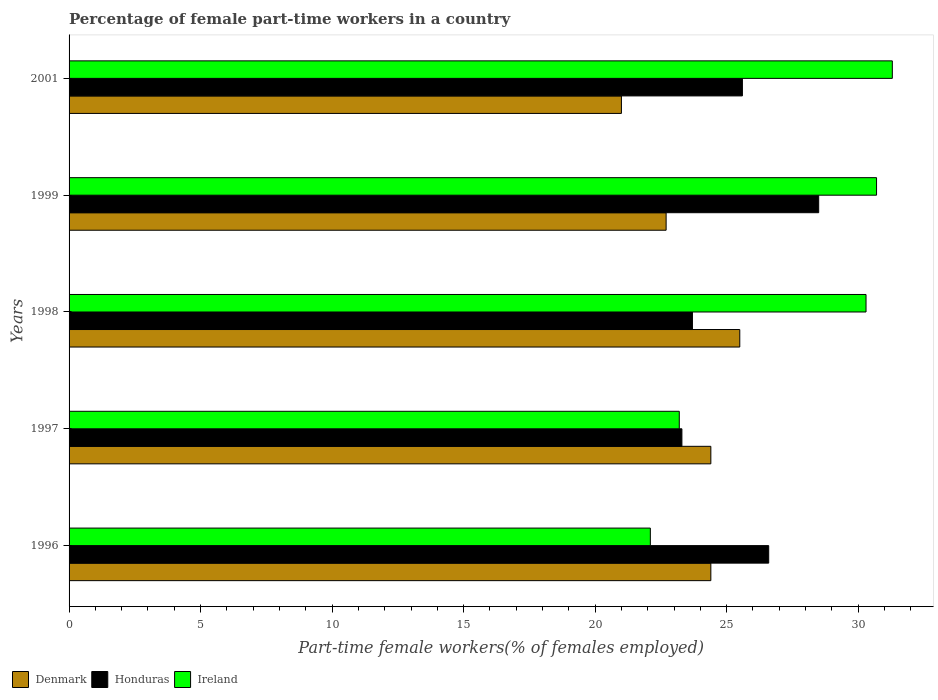How many different coloured bars are there?
Your answer should be compact. 3. Are the number of bars per tick equal to the number of legend labels?
Your answer should be compact. Yes. How many bars are there on the 4th tick from the bottom?
Keep it short and to the point. 3. What is the label of the 1st group of bars from the top?
Offer a terse response. 2001. What is the percentage of female part-time workers in Denmark in 1998?
Offer a very short reply. 25.5. In which year was the percentage of female part-time workers in Honduras minimum?
Give a very brief answer. 1997. What is the total percentage of female part-time workers in Honduras in the graph?
Your answer should be very brief. 127.7. What is the difference between the percentage of female part-time workers in Honduras in 1998 and that in 1999?
Provide a short and direct response. -4.8. What is the difference between the percentage of female part-time workers in Denmark in 1998 and the percentage of female part-time workers in Honduras in 2001?
Offer a terse response. -0.1. What is the average percentage of female part-time workers in Denmark per year?
Keep it short and to the point. 23.6. In the year 1997, what is the difference between the percentage of female part-time workers in Ireland and percentage of female part-time workers in Denmark?
Provide a succinct answer. -1.2. In how many years, is the percentage of female part-time workers in Ireland greater than 17 %?
Offer a terse response. 5. What is the ratio of the percentage of female part-time workers in Ireland in 1996 to that in 1997?
Provide a succinct answer. 0.95. What is the difference between the highest and the second highest percentage of female part-time workers in Honduras?
Keep it short and to the point. 1.9. What is the difference between the highest and the lowest percentage of female part-time workers in Ireland?
Your answer should be very brief. 9.2. What does the 2nd bar from the top in 1996 represents?
Provide a succinct answer. Honduras. Are all the bars in the graph horizontal?
Your answer should be compact. Yes. How many years are there in the graph?
Keep it short and to the point. 5. Are the values on the major ticks of X-axis written in scientific E-notation?
Keep it short and to the point. No. Where does the legend appear in the graph?
Your answer should be very brief. Bottom left. How many legend labels are there?
Provide a succinct answer. 3. What is the title of the graph?
Offer a very short reply. Percentage of female part-time workers in a country. Does "Lithuania" appear as one of the legend labels in the graph?
Give a very brief answer. No. What is the label or title of the X-axis?
Give a very brief answer. Part-time female workers(% of females employed). What is the Part-time female workers(% of females employed) of Denmark in 1996?
Your answer should be compact. 24.4. What is the Part-time female workers(% of females employed) in Honduras in 1996?
Provide a succinct answer. 26.6. What is the Part-time female workers(% of females employed) in Ireland in 1996?
Your answer should be very brief. 22.1. What is the Part-time female workers(% of females employed) in Denmark in 1997?
Your response must be concise. 24.4. What is the Part-time female workers(% of females employed) in Honduras in 1997?
Offer a very short reply. 23.3. What is the Part-time female workers(% of females employed) of Ireland in 1997?
Your answer should be compact. 23.2. What is the Part-time female workers(% of females employed) in Honduras in 1998?
Provide a short and direct response. 23.7. What is the Part-time female workers(% of females employed) in Ireland in 1998?
Ensure brevity in your answer.  30.3. What is the Part-time female workers(% of females employed) of Denmark in 1999?
Your response must be concise. 22.7. What is the Part-time female workers(% of females employed) of Ireland in 1999?
Your answer should be compact. 30.7. What is the Part-time female workers(% of females employed) in Honduras in 2001?
Offer a very short reply. 25.6. What is the Part-time female workers(% of females employed) of Ireland in 2001?
Your response must be concise. 31.3. Across all years, what is the maximum Part-time female workers(% of females employed) in Denmark?
Offer a very short reply. 25.5. Across all years, what is the maximum Part-time female workers(% of females employed) in Honduras?
Give a very brief answer. 28.5. Across all years, what is the maximum Part-time female workers(% of females employed) of Ireland?
Make the answer very short. 31.3. Across all years, what is the minimum Part-time female workers(% of females employed) of Honduras?
Give a very brief answer. 23.3. Across all years, what is the minimum Part-time female workers(% of females employed) of Ireland?
Make the answer very short. 22.1. What is the total Part-time female workers(% of females employed) of Denmark in the graph?
Your answer should be compact. 118. What is the total Part-time female workers(% of females employed) in Honduras in the graph?
Offer a very short reply. 127.7. What is the total Part-time female workers(% of females employed) in Ireland in the graph?
Make the answer very short. 137.6. What is the difference between the Part-time female workers(% of females employed) in Denmark in 1996 and that in 1997?
Your answer should be compact. 0. What is the difference between the Part-time female workers(% of females employed) in Honduras in 1996 and that in 1997?
Provide a short and direct response. 3.3. What is the difference between the Part-time female workers(% of females employed) in Ireland in 1996 and that in 1997?
Ensure brevity in your answer.  -1.1. What is the difference between the Part-time female workers(% of females employed) of Honduras in 1996 and that in 2001?
Ensure brevity in your answer.  1. What is the difference between the Part-time female workers(% of females employed) of Honduras in 1997 and that in 1998?
Your response must be concise. -0.4. What is the difference between the Part-time female workers(% of females employed) of Ireland in 1997 and that in 1998?
Provide a short and direct response. -7.1. What is the difference between the Part-time female workers(% of females employed) in Denmark in 1997 and that in 1999?
Offer a very short reply. 1.7. What is the difference between the Part-time female workers(% of females employed) of Ireland in 1997 and that in 2001?
Your answer should be very brief. -8.1. What is the difference between the Part-time female workers(% of females employed) of Denmark in 1998 and that in 1999?
Give a very brief answer. 2.8. What is the difference between the Part-time female workers(% of females employed) of Honduras in 1998 and that in 1999?
Make the answer very short. -4.8. What is the difference between the Part-time female workers(% of females employed) in Ireland in 1998 and that in 1999?
Ensure brevity in your answer.  -0.4. What is the difference between the Part-time female workers(% of females employed) in Honduras in 1998 and that in 2001?
Provide a short and direct response. -1.9. What is the difference between the Part-time female workers(% of females employed) in Ireland in 1998 and that in 2001?
Offer a terse response. -1. What is the difference between the Part-time female workers(% of females employed) in Ireland in 1999 and that in 2001?
Offer a terse response. -0.6. What is the difference between the Part-time female workers(% of females employed) of Honduras in 1996 and the Part-time female workers(% of females employed) of Ireland in 1997?
Your response must be concise. 3.4. What is the difference between the Part-time female workers(% of females employed) of Denmark in 1996 and the Part-time female workers(% of females employed) of Honduras in 1998?
Keep it short and to the point. 0.7. What is the difference between the Part-time female workers(% of females employed) of Denmark in 1996 and the Part-time female workers(% of females employed) of Ireland in 1998?
Provide a succinct answer. -5.9. What is the difference between the Part-time female workers(% of females employed) of Denmark in 1996 and the Part-time female workers(% of females employed) of Ireland in 1999?
Give a very brief answer. -6.3. What is the difference between the Part-time female workers(% of females employed) of Honduras in 1996 and the Part-time female workers(% of females employed) of Ireland in 1999?
Keep it short and to the point. -4.1. What is the difference between the Part-time female workers(% of females employed) of Denmark in 1996 and the Part-time female workers(% of females employed) of Honduras in 2001?
Offer a very short reply. -1.2. What is the difference between the Part-time female workers(% of females employed) of Denmark in 1996 and the Part-time female workers(% of females employed) of Ireland in 2001?
Your answer should be compact. -6.9. What is the difference between the Part-time female workers(% of females employed) of Honduras in 1996 and the Part-time female workers(% of females employed) of Ireland in 2001?
Offer a terse response. -4.7. What is the difference between the Part-time female workers(% of females employed) of Honduras in 1997 and the Part-time female workers(% of females employed) of Ireland in 1998?
Offer a very short reply. -7. What is the difference between the Part-time female workers(% of females employed) in Denmark in 1997 and the Part-time female workers(% of females employed) in Honduras in 1999?
Your answer should be very brief. -4.1. What is the difference between the Part-time female workers(% of females employed) in Denmark in 1997 and the Part-time female workers(% of females employed) in Ireland in 1999?
Your answer should be compact. -6.3. What is the difference between the Part-time female workers(% of females employed) in Honduras in 1997 and the Part-time female workers(% of females employed) in Ireland in 1999?
Your answer should be compact. -7.4. What is the difference between the Part-time female workers(% of females employed) in Honduras in 1997 and the Part-time female workers(% of females employed) in Ireland in 2001?
Your response must be concise. -8. What is the difference between the Part-time female workers(% of females employed) of Denmark in 1998 and the Part-time female workers(% of females employed) of Ireland in 1999?
Keep it short and to the point. -5.2. What is the difference between the Part-time female workers(% of females employed) in Honduras in 1998 and the Part-time female workers(% of females employed) in Ireland in 1999?
Keep it short and to the point. -7. What is the difference between the Part-time female workers(% of females employed) in Denmark in 1998 and the Part-time female workers(% of females employed) in Honduras in 2001?
Your response must be concise. -0.1. What is the difference between the Part-time female workers(% of females employed) of Honduras in 1998 and the Part-time female workers(% of females employed) of Ireland in 2001?
Offer a terse response. -7.6. What is the average Part-time female workers(% of females employed) of Denmark per year?
Your response must be concise. 23.6. What is the average Part-time female workers(% of females employed) in Honduras per year?
Make the answer very short. 25.54. What is the average Part-time female workers(% of females employed) in Ireland per year?
Provide a succinct answer. 27.52. In the year 1996, what is the difference between the Part-time female workers(% of females employed) in Denmark and Part-time female workers(% of females employed) in Ireland?
Your answer should be very brief. 2.3. In the year 1997, what is the difference between the Part-time female workers(% of females employed) in Denmark and Part-time female workers(% of females employed) in Ireland?
Offer a terse response. 1.2. In the year 1998, what is the difference between the Part-time female workers(% of females employed) of Denmark and Part-time female workers(% of females employed) of Honduras?
Offer a terse response. 1.8. In the year 1998, what is the difference between the Part-time female workers(% of females employed) of Honduras and Part-time female workers(% of females employed) of Ireland?
Keep it short and to the point. -6.6. In the year 1999, what is the difference between the Part-time female workers(% of females employed) in Denmark and Part-time female workers(% of females employed) in Honduras?
Your answer should be very brief. -5.8. In the year 2001, what is the difference between the Part-time female workers(% of females employed) in Denmark and Part-time female workers(% of females employed) in Honduras?
Ensure brevity in your answer.  -4.6. In the year 2001, what is the difference between the Part-time female workers(% of females employed) in Denmark and Part-time female workers(% of females employed) in Ireland?
Provide a succinct answer. -10.3. In the year 2001, what is the difference between the Part-time female workers(% of females employed) in Honduras and Part-time female workers(% of females employed) in Ireland?
Offer a very short reply. -5.7. What is the ratio of the Part-time female workers(% of females employed) in Denmark in 1996 to that in 1997?
Your response must be concise. 1. What is the ratio of the Part-time female workers(% of females employed) in Honduras in 1996 to that in 1997?
Your response must be concise. 1.14. What is the ratio of the Part-time female workers(% of females employed) of Ireland in 1996 to that in 1997?
Keep it short and to the point. 0.95. What is the ratio of the Part-time female workers(% of females employed) of Denmark in 1996 to that in 1998?
Your answer should be very brief. 0.96. What is the ratio of the Part-time female workers(% of females employed) of Honduras in 1996 to that in 1998?
Give a very brief answer. 1.12. What is the ratio of the Part-time female workers(% of females employed) of Ireland in 1996 to that in 1998?
Offer a terse response. 0.73. What is the ratio of the Part-time female workers(% of females employed) in Denmark in 1996 to that in 1999?
Your response must be concise. 1.07. What is the ratio of the Part-time female workers(% of females employed) of Ireland in 1996 to that in 1999?
Give a very brief answer. 0.72. What is the ratio of the Part-time female workers(% of females employed) of Denmark in 1996 to that in 2001?
Your answer should be compact. 1.16. What is the ratio of the Part-time female workers(% of females employed) of Honduras in 1996 to that in 2001?
Your answer should be very brief. 1.04. What is the ratio of the Part-time female workers(% of females employed) in Ireland in 1996 to that in 2001?
Your answer should be very brief. 0.71. What is the ratio of the Part-time female workers(% of females employed) in Denmark in 1997 to that in 1998?
Ensure brevity in your answer.  0.96. What is the ratio of the Part-time female workers(% of females employed) of Honduras in 1997 to that in 1998?
Offer a terse response. 0.98. What is the ratio of the Part-time female workers(% of females employed) of Ireland in 1997 to that in 1998?
Ensure brevity in your answer.  0.77. What is the ratio of the Part-time female workers(% of females employed) in Denmark in 1997 to that in 1999?
Your answer should be compact. 1.07. What is the ratio of the Part-time female workers(% of females employed) of Honduras in 1997 to that in 1999?
Keep it short and to the point. 0.82. What is the ratio of the Part-time female workers(% of females employed) in Ireland in 1997 to that in 1999?
Ensure brevity in your answer.  0.76. What is the ratio of the Part-time female workers(% of females employed) of Denmark in 1997 to that in 2001?
Give a very brief answer. 1.16. What is the ratio of the Part-time female workers(% of females employed) of Honduras in 1997 to that in 2001?
Your response must be concise. 0.91. What is the ratio of the Part-time female workers(% of females employed) in Ireland in 1997 to that in 2001?
Offer a terse response. 0.74. What is the ratio of the Part-time female workers(% of females employed) in Denmark in 1998 to that in 1999?
Make the answer very short. 1.12. What is the ratio of the Part-time female workers(% of females employed) in Honduras in 1998 to that in 1999?
Provide a short and direct response. 0.83. What is the ratio of the Part-time female workers(% of females employed) in Ireland in 1998 to that in 1999?
Keep it short and to the point. 0.99. What is the ratio of the Part-time female workers(% of females employed) in Denmark in 1998 to that in 2001?
Offer a very short reply. 1.21. What is the ratio of the Part-time female workers(% of females employed) in Honduras in 1998 to that in 2001?
Offer a very short reply. 0.93. What is the ratio of the Part-time female workers(% of females employed) of Ireland in 1998 to that in 2001?
Keep it short and to the point. 0.97. What is the ratio of the Part-time female workers(% of females employed) of Denmark in 1999 to that in 2001?
Make the answer very short. 1.08. What is the ratio of the Part-time female workers(% of females employed) of Honduras in 1999 to that in 2001?
Offer a terse response. 1.11. What is the ratio of the Part-time female workers(% of females employed) in Ireland in 1999 to that in 2001?
Offer a terse response. 0.98. What is the difference between the highest and the second highest Part-time female workers(% of females employed) of Denmark?
Your answer should be very brief. 1.1. What is the difference between the highest and the second highest Part-time female workers(% of females employed) in Ireland?
Your answer should be very brief. 0.6. What is the difference between the highest and the lowest Part-time female workers(% of females employed) in Denmark?
Make the answer very short. 4.5. What is the difference between the highest and the lowest Part-time female workers(% of females employed) of Honduras?
Provide a succinct answer. 5.2. 